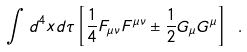<formula> <loc_0><loc_0><loc_500><loc_500>\int d ^ { 4 } x d \tau \left [ \frac { 1 } { 4 } F _ { \mu \nu } F ^ { \mu \nu } \pm \frac { 1 } { 2 } G _ { \mu } G ^ { \mu } \right ] \ .</formula> 